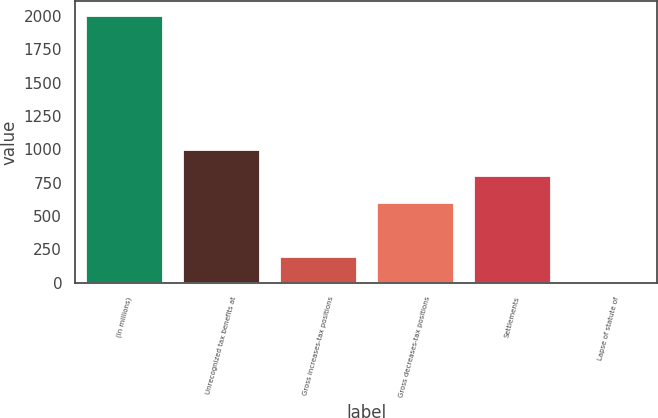<chart> <loc_0><loc_0><loc_500><loc_500><bar_chart><fcel>(In millions)<fcel>Unrecognized tax benefits at<fcel>Gross increases-tax positions<fcel>Gross decreases-tax positions<fcel>Settlements<fcel>Lapse of statute of<nl><fcel>2011<fcel>1005.6<fcel>201.28<fcel>603.44<fcel>804.52<fcel>0.2<nl></chart> 